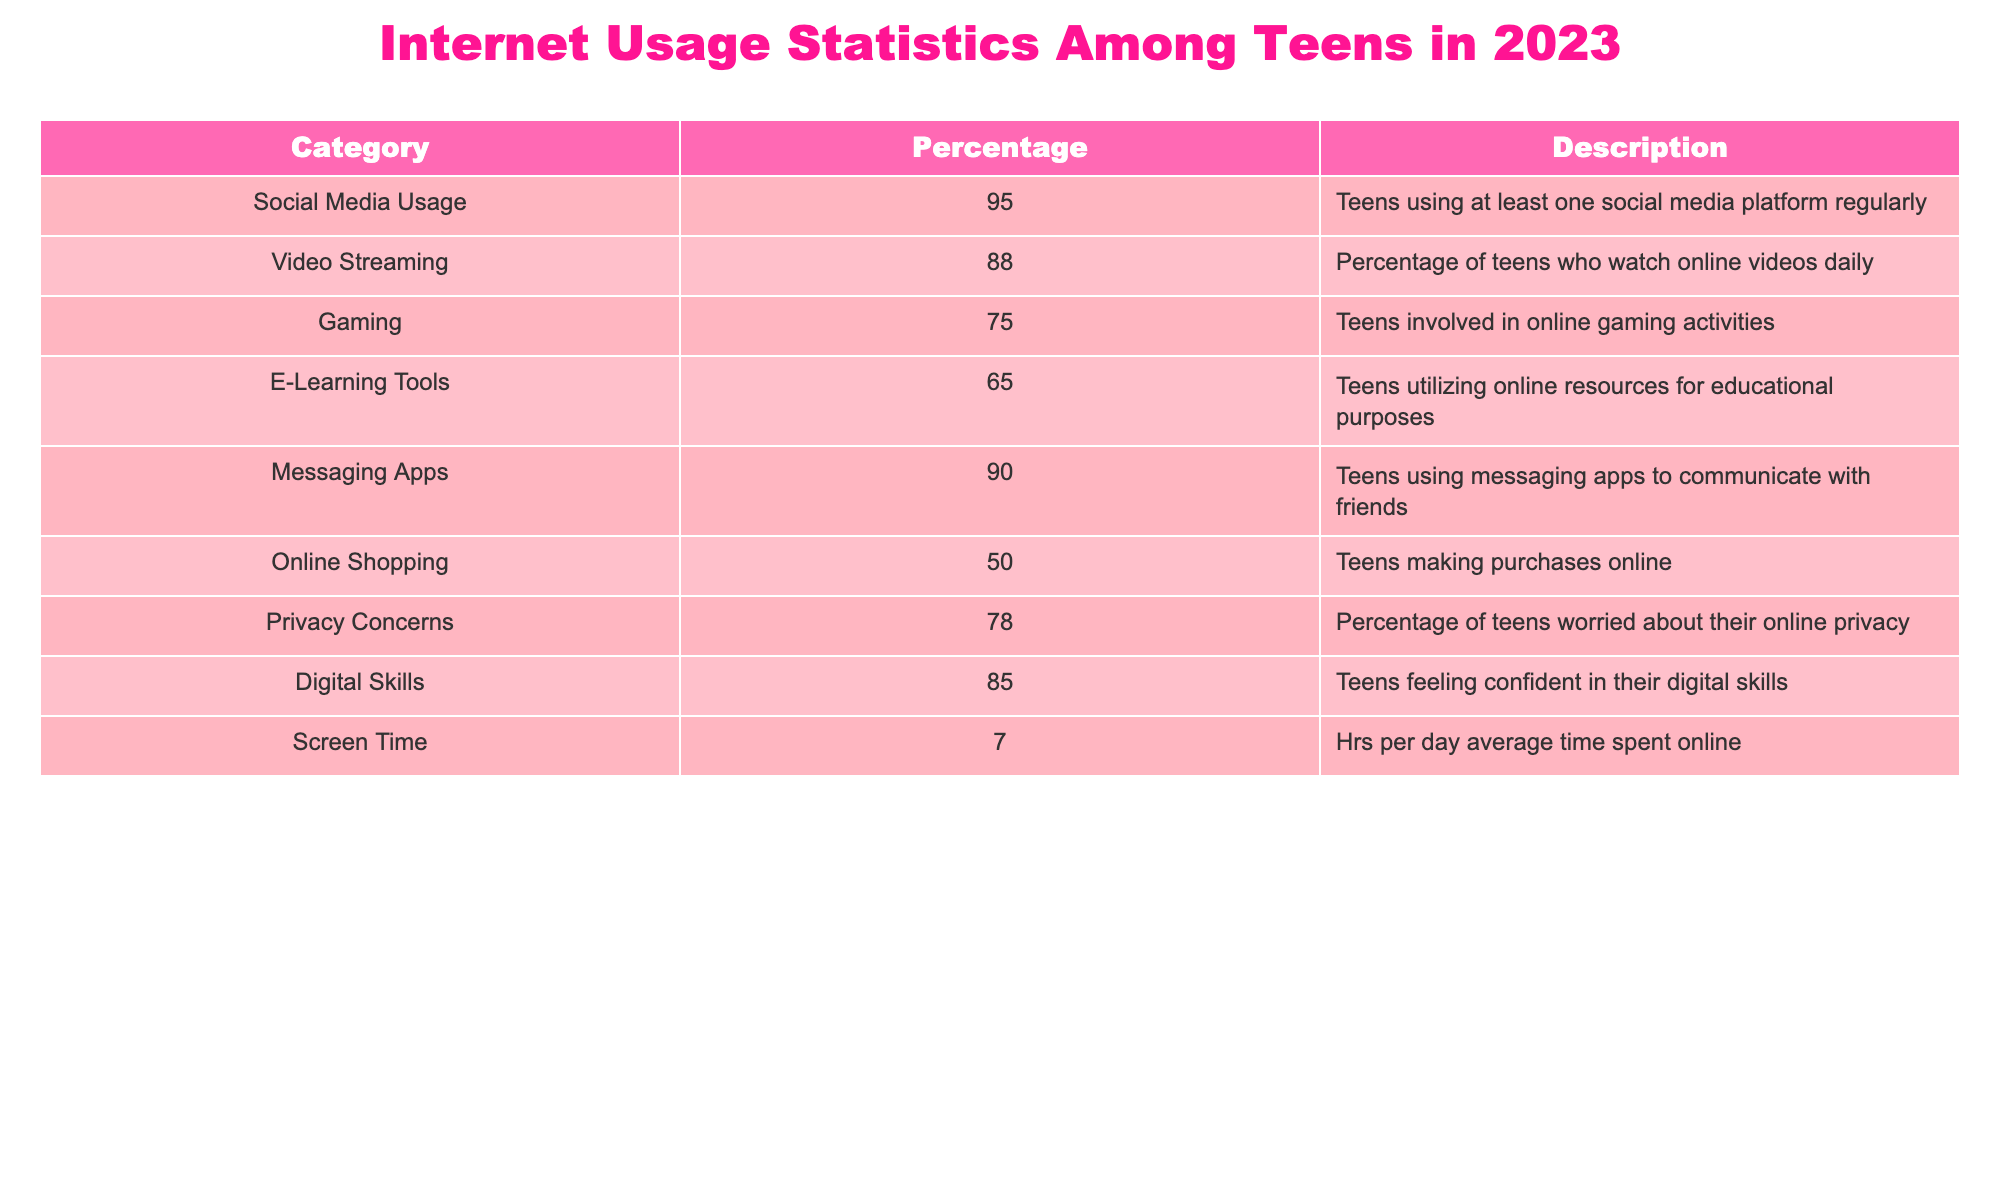What percentage of teens use social media? The table shows that 95% of teens use at least one social media platform regularly.
Answer: 95% What is the percentage of teens who have privacy concerns? According to the table, 78% of teens are worried about their online privacy.
Answer: 78% What is the difference between the percentage of teens using messaging apps and those involved in online gaming? The percentage of teens using messaging apps is 90%, while those involved in online gaming is 75%. The difference is 90% - 75% = 15%.
Answer: 15% Is the percentage of teenagers using e-learning tools greater than those making online purchases? The table indicates that 65% of teens utilize e-learning tools while 50% make online purchases, confirming that the former is greater than the latter.
Answer: Yes What is the average percentage of teens using social media, video streaming, and messaging apps? First, we sum the percentages: 95% + 88% + 90% = 273%. Then we divide by 3 to find the average: 273% / 3 = 91%.
Answer: 91% What percentage of teens watch online videos daily? The table lists that 88% of teens watch online videos daily.
Answer: 88% What is the percentage of teens who utilize digital skills? From the table, we find that 85% of teens feel confident in their digital skills.
Answer: 85% Are more teens involved in online gaming than those using e-learning tools? The table shows that 75% of teens are involved in gaming, while 65% use e-learning tools, indicating that more teens are involved in gaming.
Answer: Yes If you combine the percentages of teens using both social media and messaging apps, what is the total? The percentage of teens using social media is 95% and those using messaging apps is 90%. Thus, the total is 95% + 90% = 185%.
Answer: 185% 